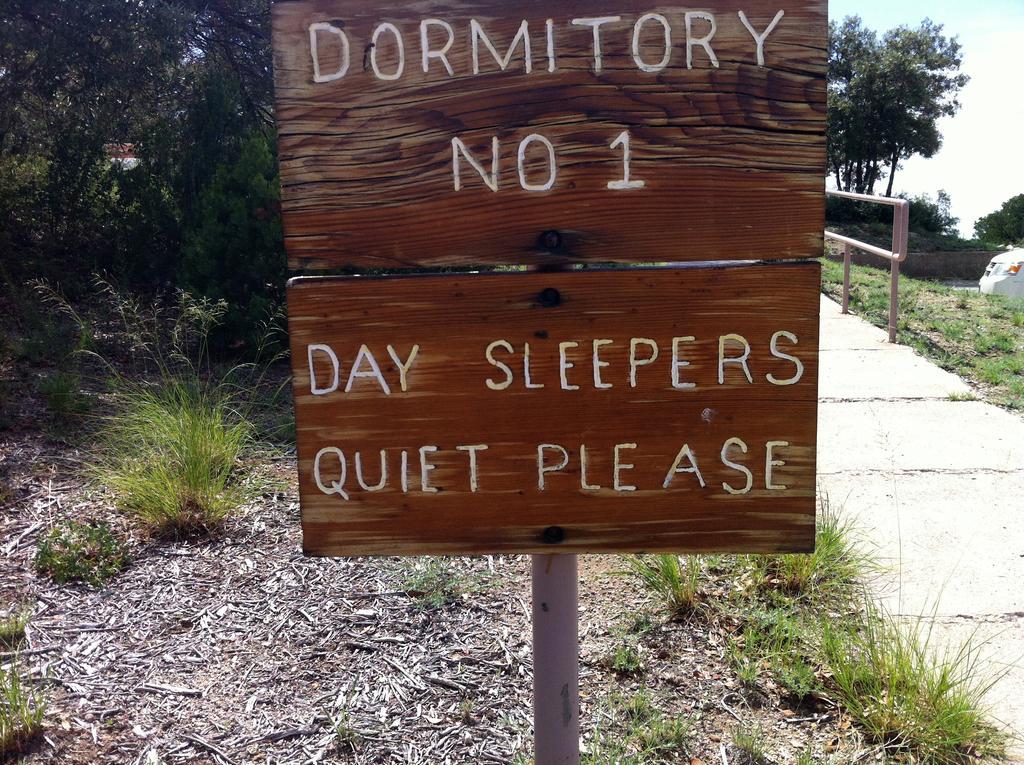In one or two sentences, can you explain what this image depicts? In the center of the image, there is a signboard and on the bottom right, there is a sideway and we can see a vehicle. In the background, there are trees and at the bottom, there is ground and some part is covered with grass. 